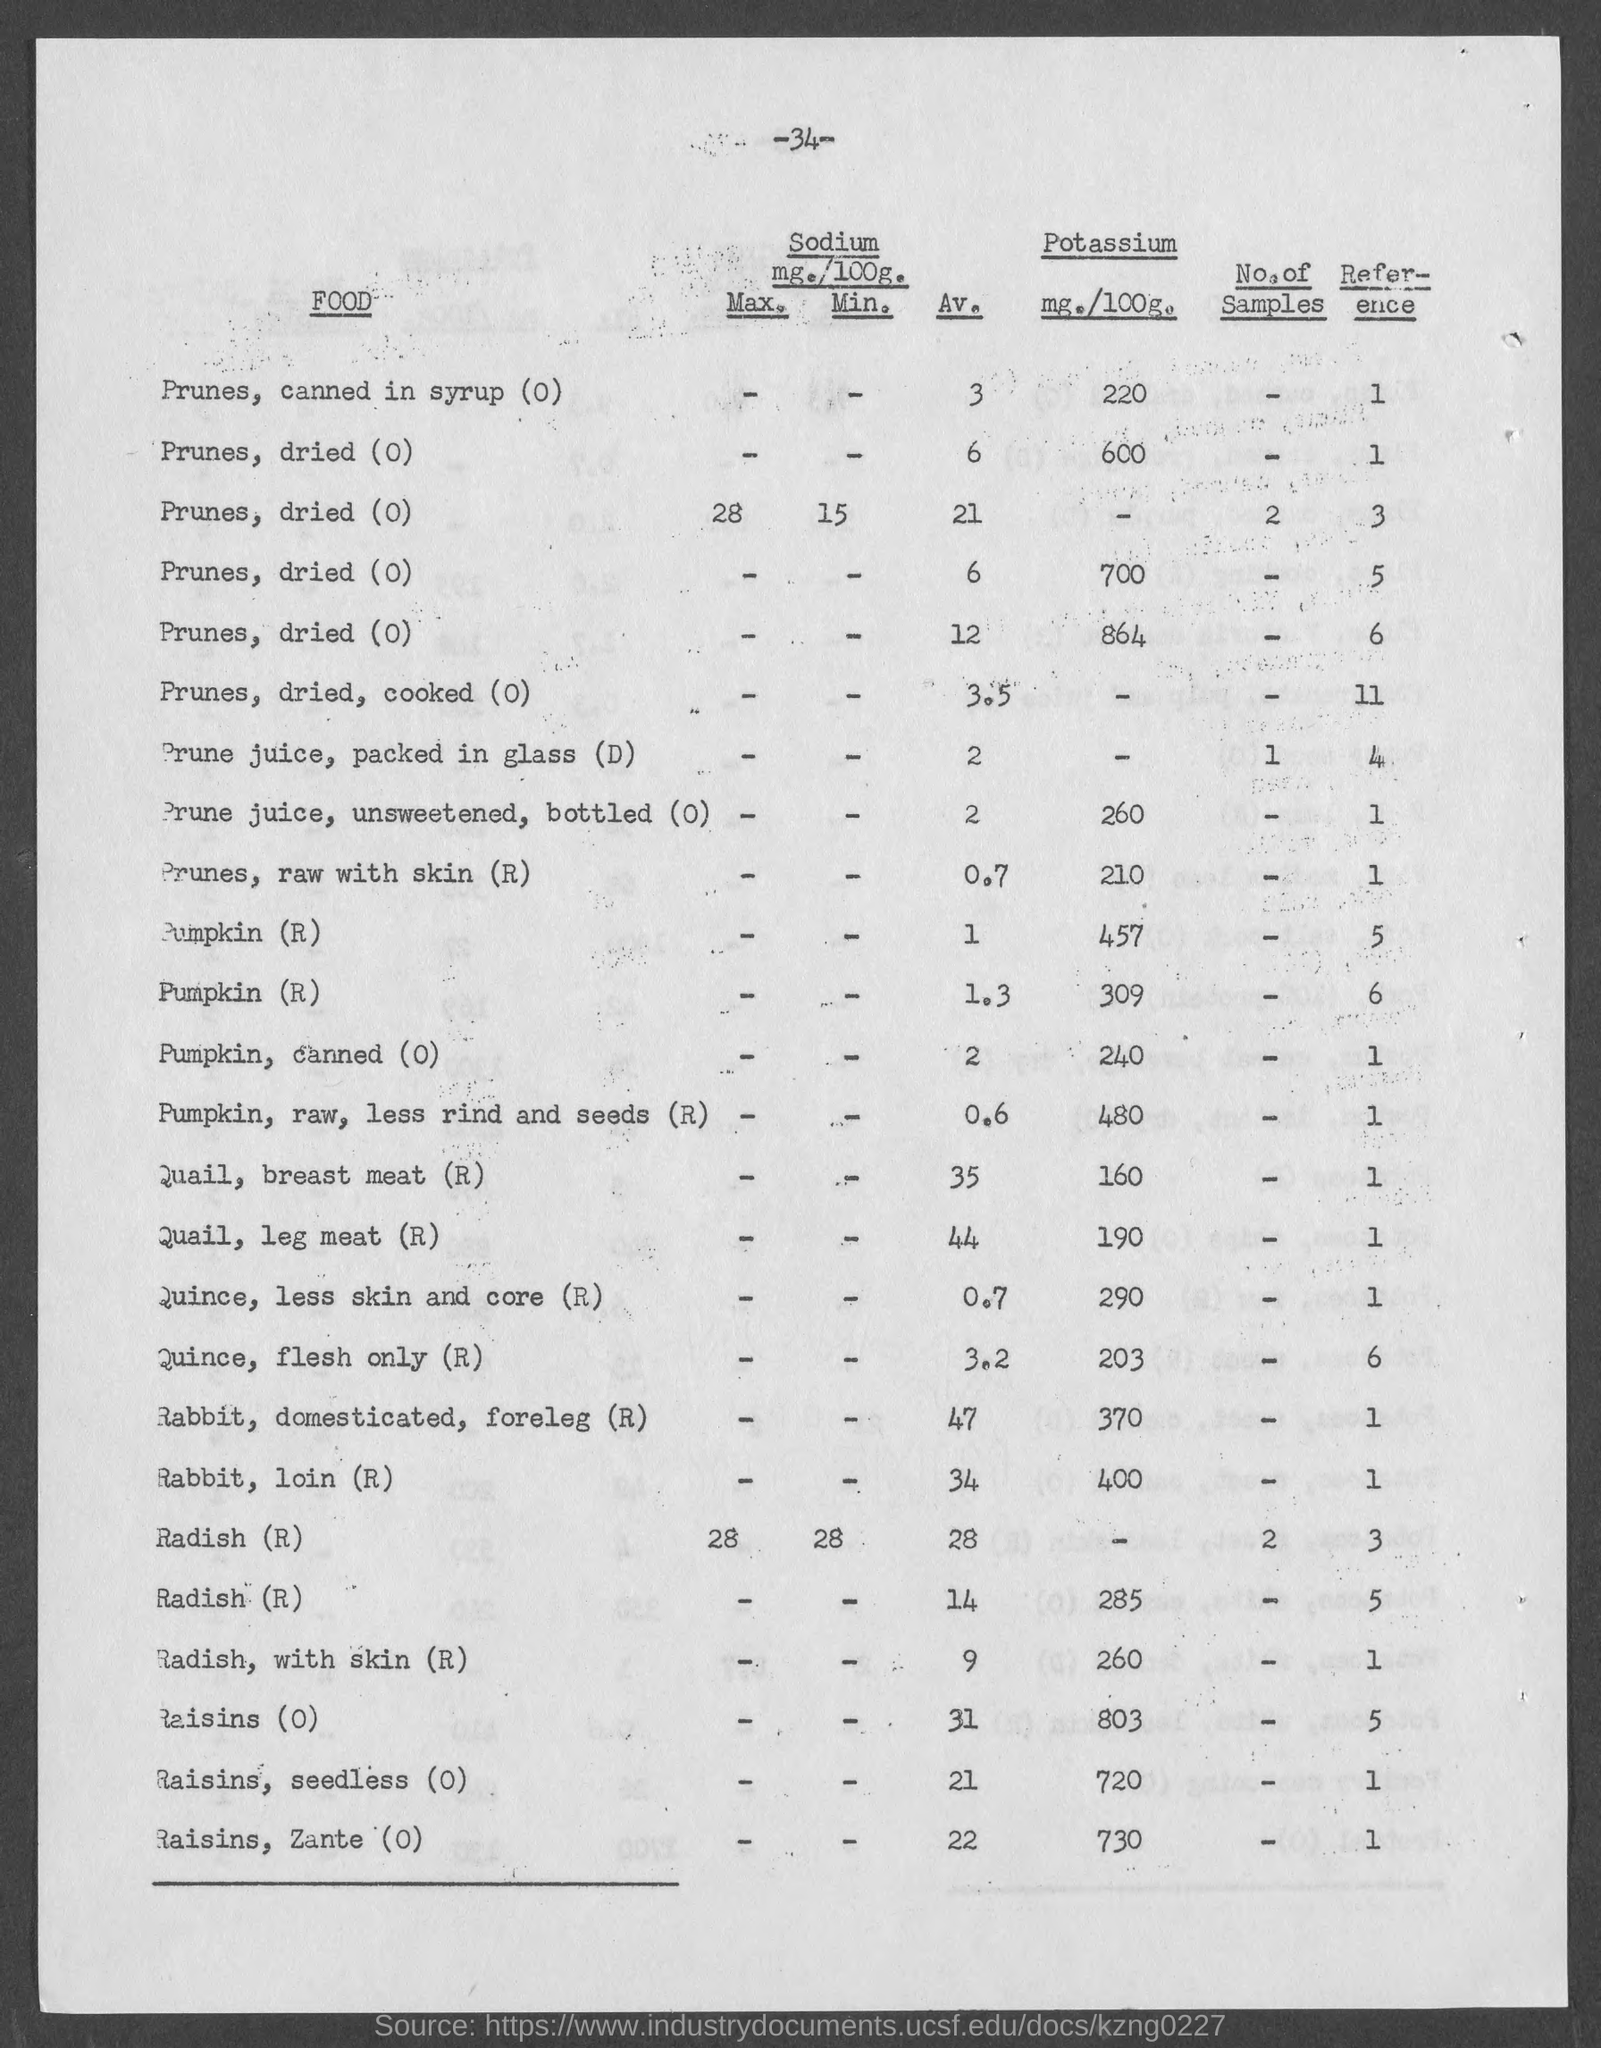What is the amount of potassium present in prunes, canned in syrup(0) as mentioned in the given page ?
Your answer should be compact. 220. What is the max. value of sodium present in prunes, dried (0) as mentioned in the given page ?
Keep it short and to the point. 28. What is the amount of potassium present in prune juice, unsweetened , bottled(0) as mentioned in the given page ? as mentioned in the given page ?
Provide a short and direct response. 260. What is the av. value of prunes,dried, cooked (0) as mentioned in the given page ?
Offer a very short reply. 3.5. What is the value of potassium present in quail, breast meat(r) as mentioned in the given page ?
Give a very brief answer. 160. What are the no. of samples present for prunes, dried (0) as mentioned in the given page ?
Your answer should be very brief. 2. What is the amount of potassium present in pumpkin, raw, less rind and seeds(r) as mentioned in the given page ?
Your answer should be compact. 480. What is the av. value of rabbit, loin(r) as mentioned in the given page ?
Your answer should be very brief. 34. 